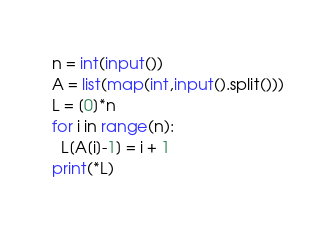Convert code to text. <code><loc_0><loc_0><loc_500><loc_500><_Python_>n = int(input())
A = list(map(int,input().split()))
L = [0]*n
for i in range(n):
  L[A[i]-1] = i + 1
print(*L)</code> 